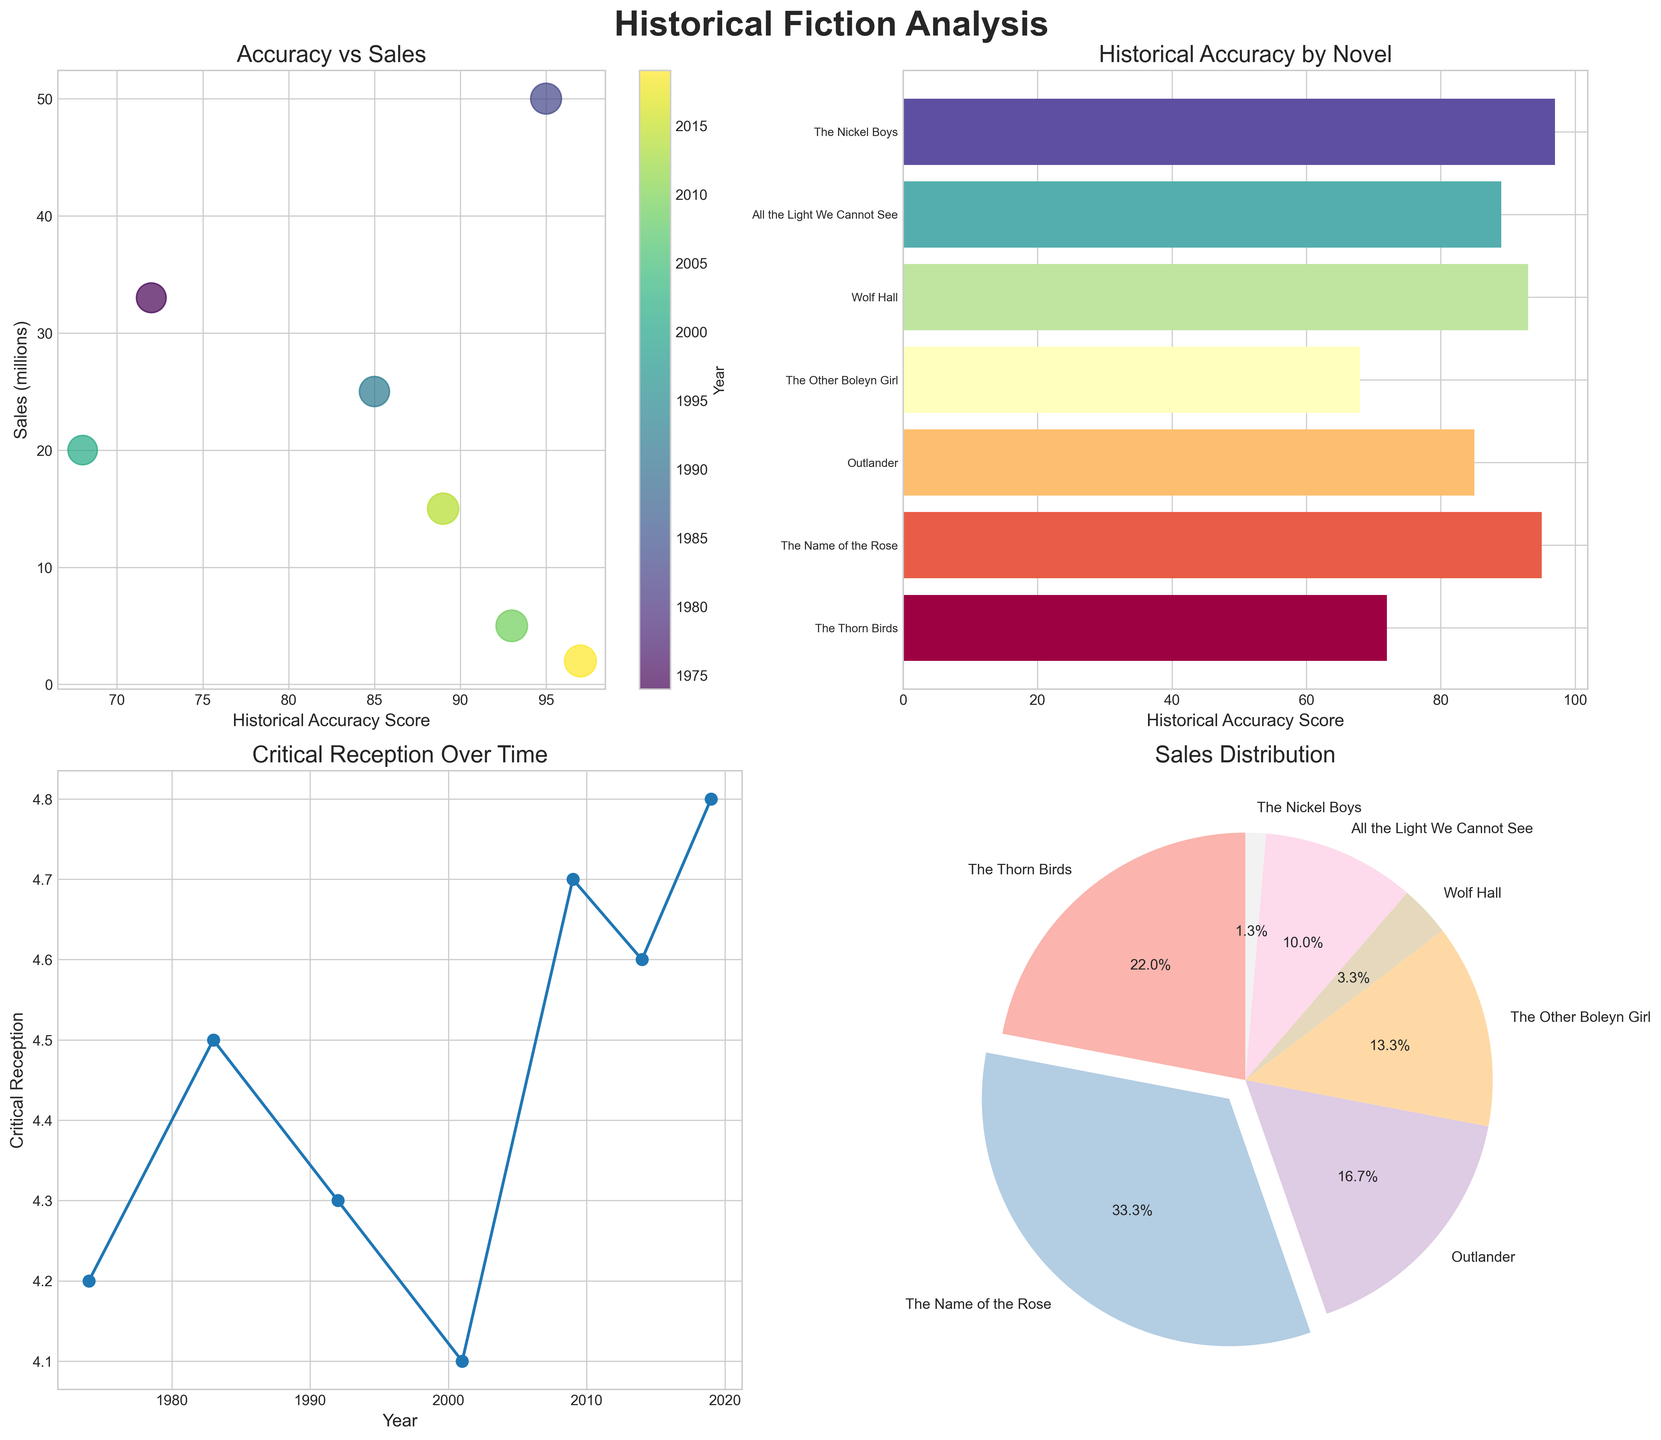What does the title of the pie chart indicate? The title of the pie chart is located above the chart and it indicates the focus of the pie chart. By reading the title, we can understand the context of the chart.
Answer: Sales Distribution Which novel has the highest historical accuracy score according to the bar plot? By examining the bars in the bar plot and their corresponding labels, we can identify which bar reaches the highest value on the x-axis labeled "Historical Accuracy Score".
Answer: The Nickel Boys How do sales and historical accuracy score relate to each other according to the scatter plot? The scatter plot shows the relationship between historical accuracy score (x-axis) and sales (y-axis). By observing the plotted points, we can describe the pattern of the data.
Answer: Scatter shows no clear correlation Between which years did the critical reception see the biggest increase according to the line plot? By observing the line plot and noting the difference in the y-values between consecutive years, we can identify the largest increase in critical reception.
Answer: 2009 to 2019 Which novel contributes the largest portion of sales according to the pie chart? The slices of the pie chart represent sales, with the largest slice indicating the novel with the most sales. The legend or labels on the chart provide the novel names.
Answer: The Name of the Rose What is the historical accuracy score of "The Other Boleyn Girl" according to the bar plot? By locating "The Other Boleyn Girl" along the y-axis of the bar plot and tracing horizontally to the x-axis, we can find the corresponding historical accuracy score.
Answer: 68 How has the critical reception for historical fiction novels changed over the past 50 years according to the line plot? Observing the trend in the plotted line on the line plot, we can identify the general direction and patterns in the critical reception numbers as years progress.
Answer: Generally increased Which two novels, according to the scatter plot, have the closest historical accuracy score? By visually assessing the positions of the points in the scatter plot, we can determine the two points that are positioned closest to each other on the x-axis.
Answer: "Outlander" and "All the Light We Cannot See" In the bar plot, which novel has a slightly higher historical accuracy score than "The Thorn Birds"? By finding the bar that represents "The Thorn Birds" and identifying the bar just slightly to the right of it, we can determine the novel with a slightly higher score.
Answer: Outlander Considering the pie chart, what is the approximate percentage of total sales represented by "All the Light We Cannot See"? By looking at the slice corresponding to "All the Light We Cannot See" and reading the percentage displayed alongside it, we can determine its contribution.
Answer: 8.6% 